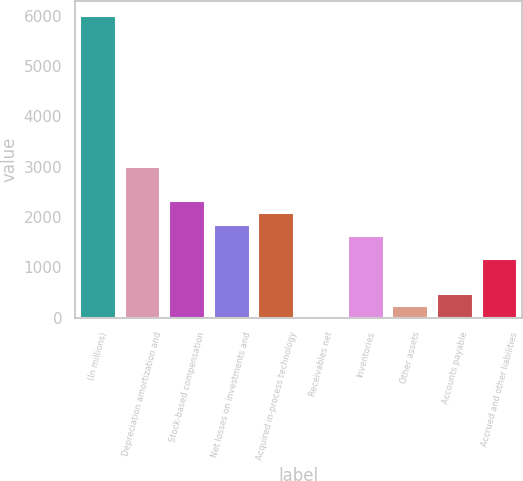<chart> <loc_0><loc_0><loc_500><loc_500><bar_chart><fcel>(In millions)<fcel>Depreciation amortization and<fcel>Stock-based compensation<fcel>Net losses on investments and<fcel>Acquired in-process technology<fcel>Receivables net<fcel>Inventories<fcel>Other assets<fcel>Accounts payable<fcel>Accrued and other liabilities<nl><fcel>5982.8<fcel>2995.4<fcel>2306<fcel>1846.4<fcel>2076.2<fcel>8<fcel>1616.6<fcel>237.8<fcel>467.6<fcel>1157<nl></chart> 